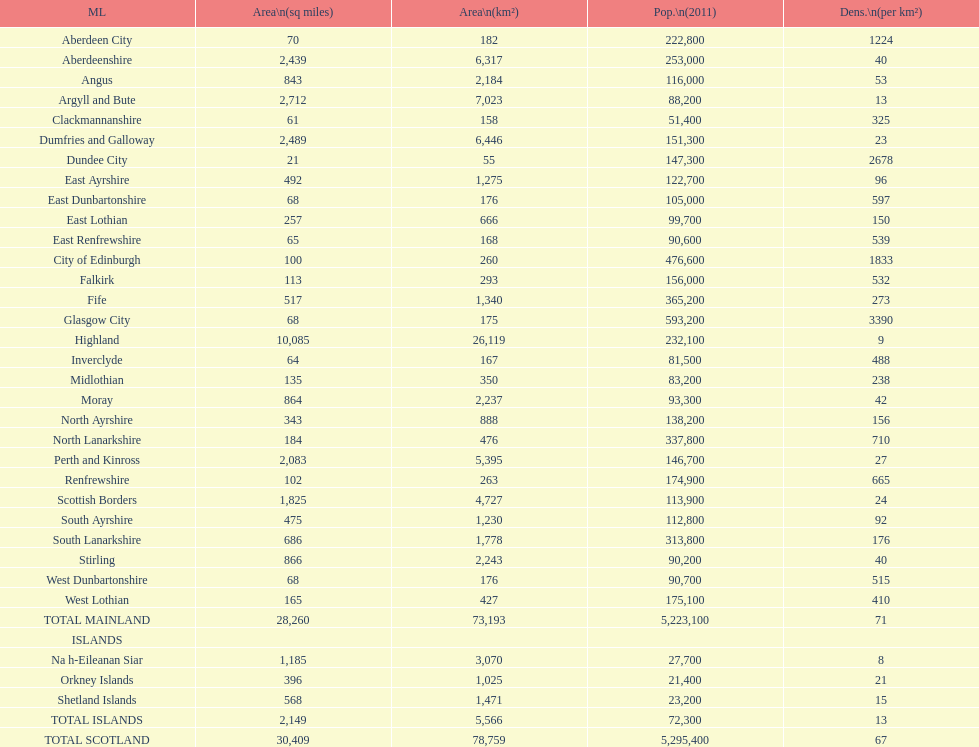What number of mainlands have populations under 100,000? 9. 